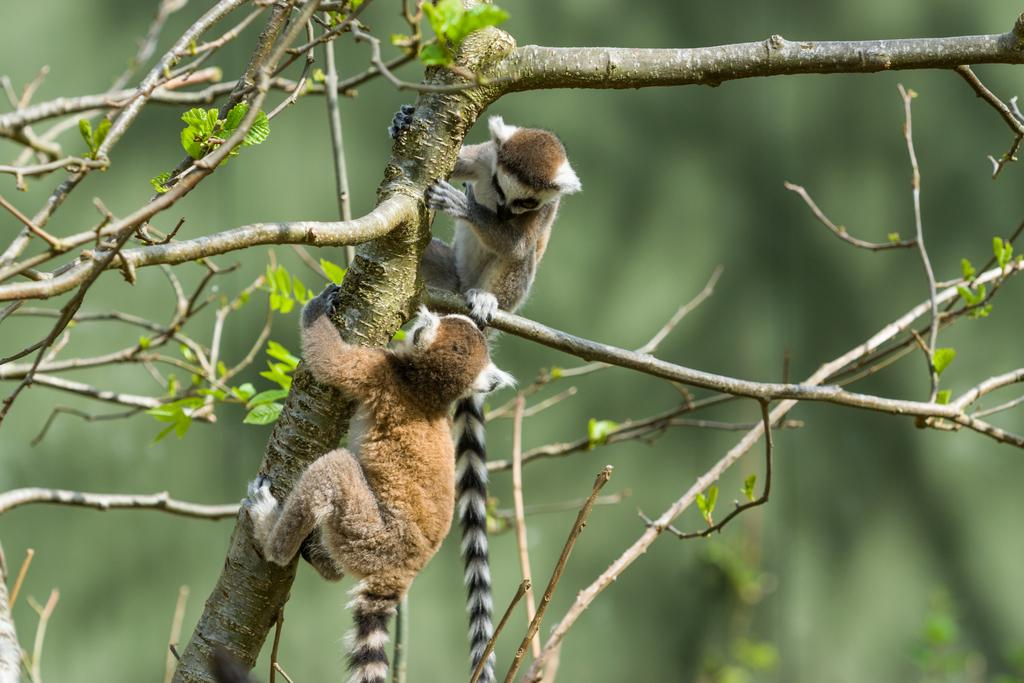What types of living organisms are present in the image? There are animals in the image. What natural elements can be seen in the image? There are branches and leaves in the image. How would you describe the background of the image? The background of the image is blurry. What type of pain can be seen on the animals' faces in the image? There is no indication of pain on the animals' faces in the image. How many flowers are visible in the image? There are no flowers present in the image. 